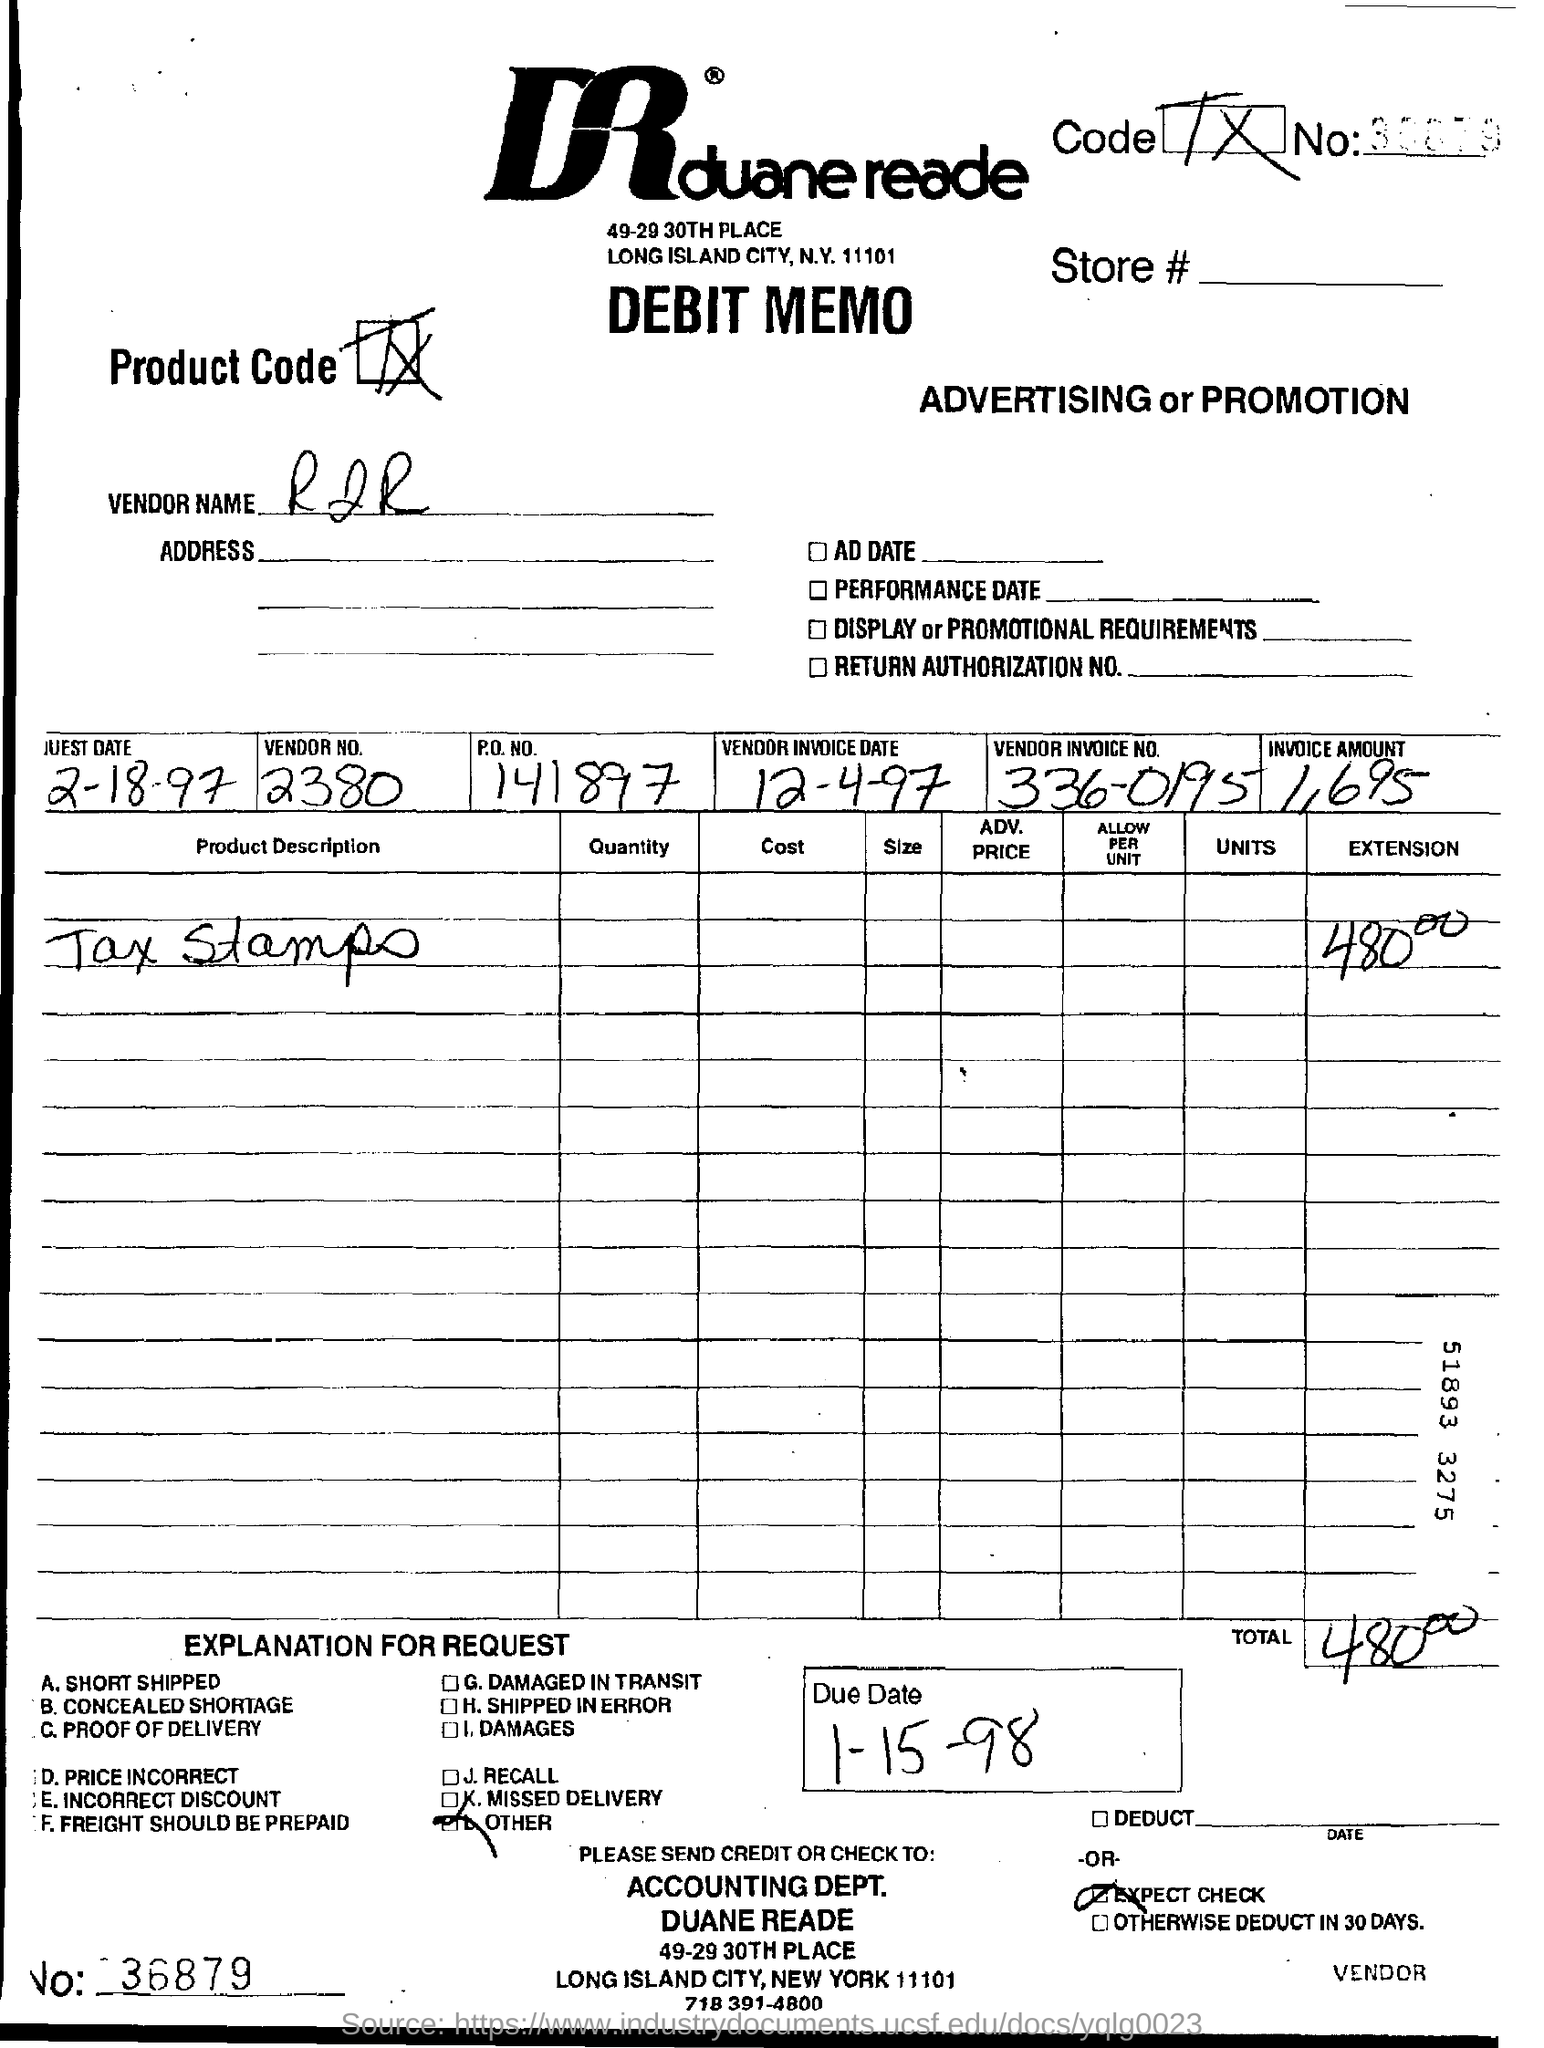Are there any signs of what the product or service might relate to? The product description on the memo is partially legible and reads 'Tax Stamp(s),' which might refer to stamps used to show that the tax on a product has been paid. The mention of advertising or promotion at the top suggests the debit could be related to marketing costs associated with these products.  Can you provide any additional context about the store or location mentioned? Duane Reade is a well-known drugstore chain primarily located in New York City, and the address '49-29 30th Place, Long Island City, NY' indicates the location of either the store, headquarters, or another office associated with the chain at the time the document was issued. 